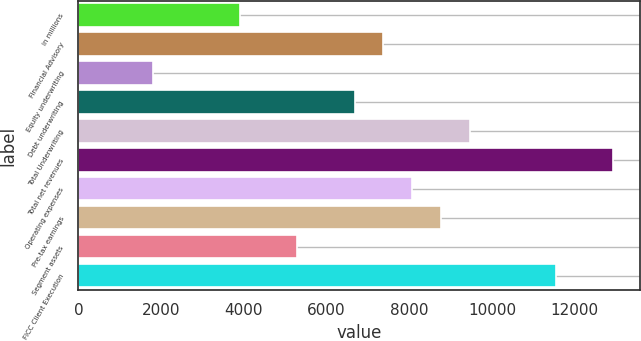Convert chart to OTSL. <chart><loc_0><loc_0><loc_500><loc_500><bar_chart><fcel>in millions<fcel>Financial Advisory<fcel>Equity underwriting<fcel>Debt underwriting<fcel>Total Underwriting<fcel>Total net revenues<fcel>Operating expenses<fcel>Pre-tax earnings<fcel>Segment assets<fcel>FICC Client Execution<nl><fcel>3894<fcel>7371<fcel>1807.8<fcel>6675.6<fcel>9457.2<fcel>12934.2<fcel>8066.4<fcel>8761.8<fcel>5284.8<fcel>11543.4<nl></chart> 